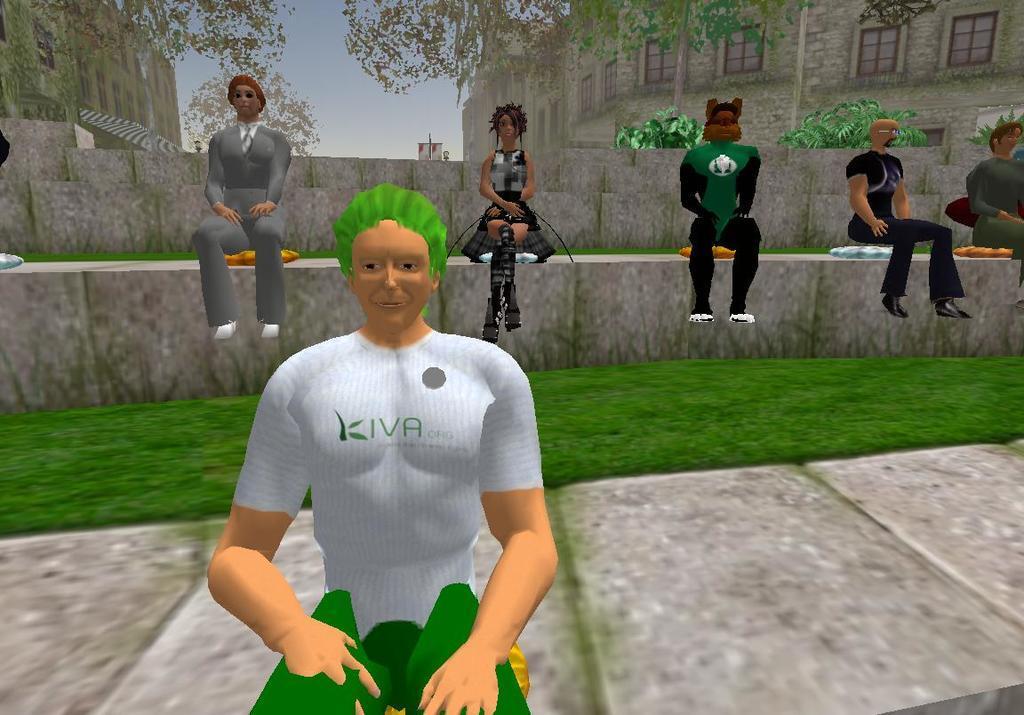Could you give a brief overview of what you see in this image? In this image we can see an animation of few persons, a grassy land, many trees, a building etc., in the image. 